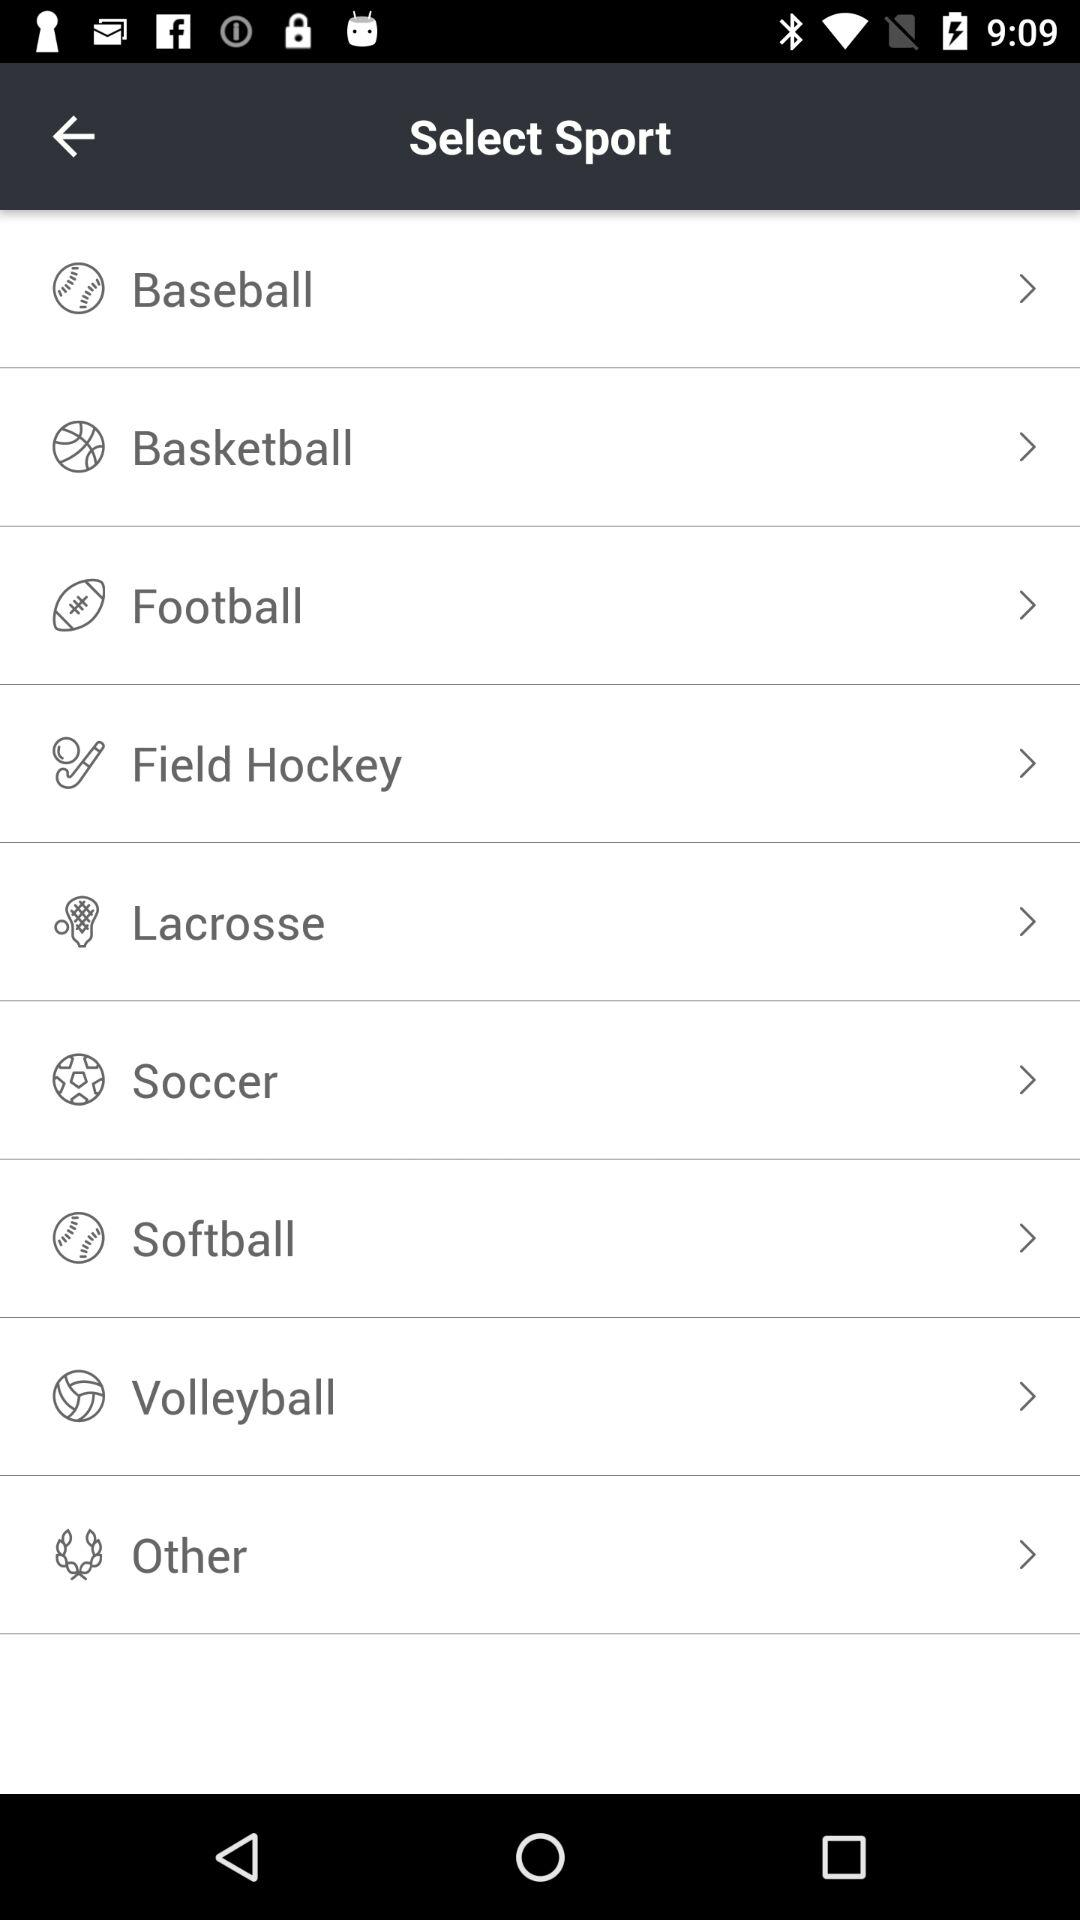What are the names of the sports available in the list? The names of the sports are "Baseball", "Basketball", "Football", "Field Hockey", "Lacrosse", "Soccer", "Softball", "Volleyball" and "Other". 